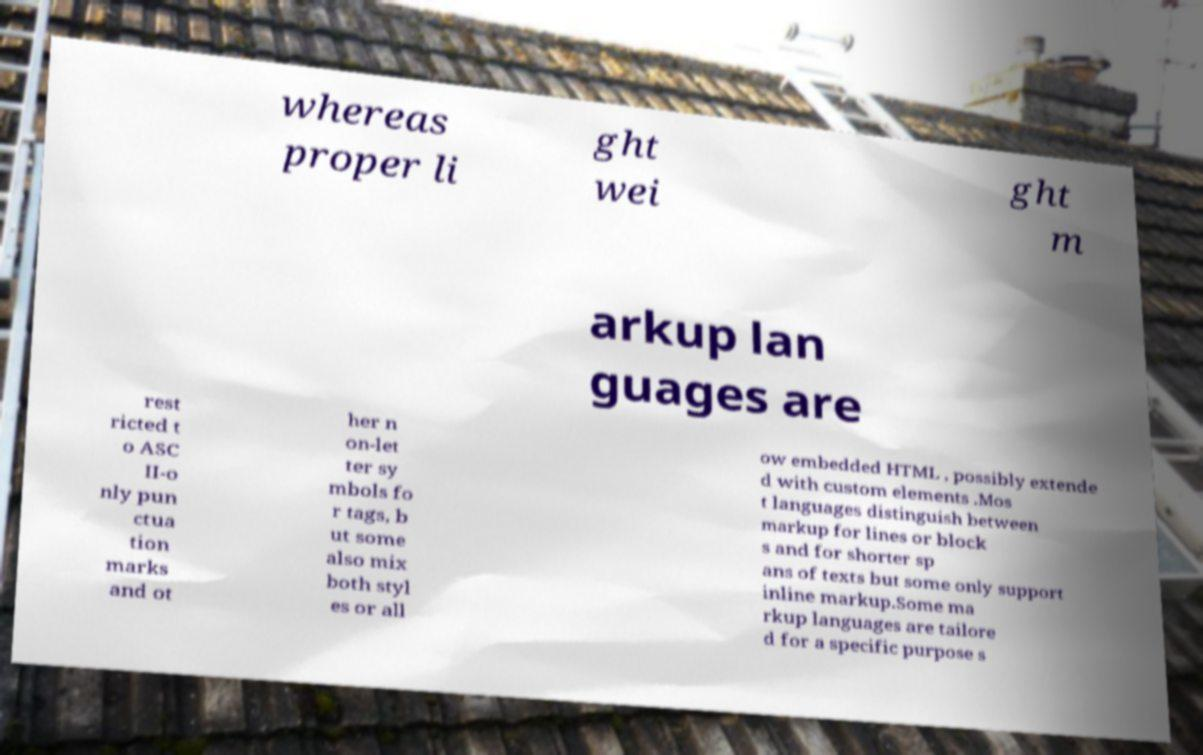Could you extract and type out the text from this image? whereas proper li ght wei ght m arkup lan guages are rest ricted t o ASC II-o nly pun ctua tion marks and ot her n on-let ter sy mbols fo r tags, b ut some also mix both styl es or all ow embedded HTML , possibly extende d with custom elements .Mos t languages distinguish between markup for lines or block s and for shorter sp ans of texts but some only support inline markup.Some ma rkup languages are tailore d for a specific purpose s 